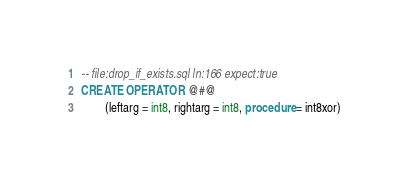Convert code to text. <code><loc_0><loc_0><loc_500><loc_500><_SQL_>-- file:drop_if_exists.sql ln:166 expect:true
CREATE OPERATOR @#@
        (leftarg = int8, rightarg = int8, procedure = int8xor)
</code> 